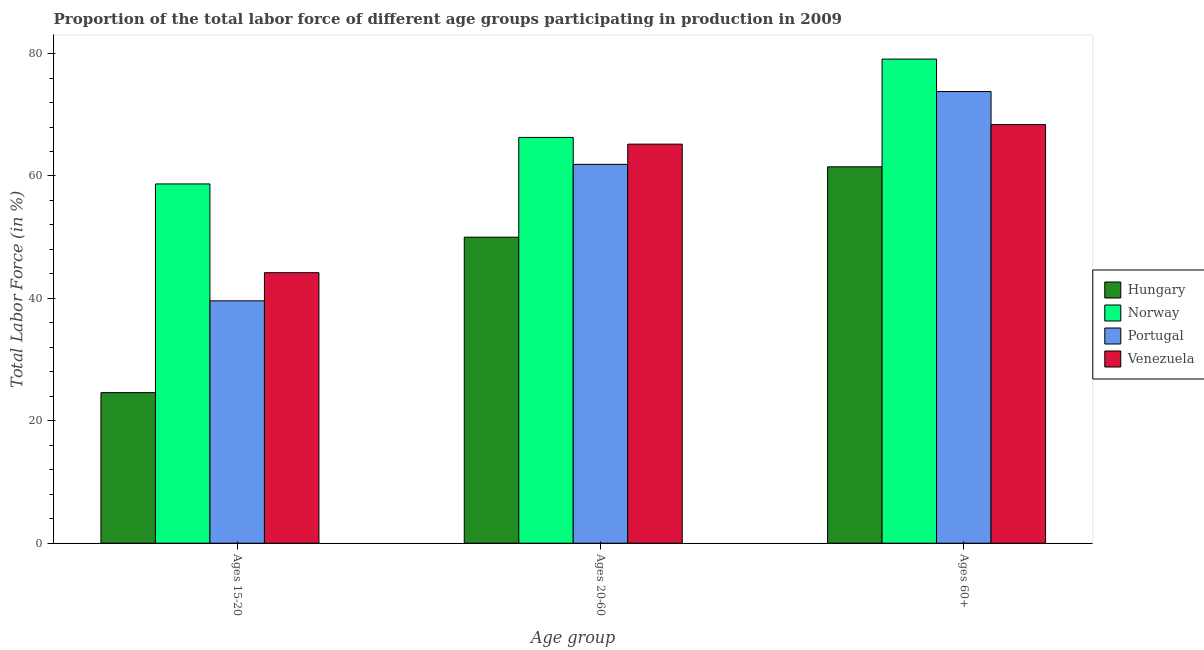How many groups of bars are there?
Your answer should be very brief. 3. Are the number of bars per tick equal to the number of legend labels?
Give a very brief answer. Yes. Are the number of bars on each tick of the X-axis equal?
Offer a very short reply. Yes. How many bars are there on the 3rd tick from the left?
Ensure brevity in your answer.  4. How many bars are there on the 3rd tick from the right?
Your answer should be compact. 4. What is the label of the 3rd group of bars from the left?
Provide a succinct answer. Ages 60+. What is the percentage of labor force above age 60 in Venezuela?
Your response must be concise. 68.4. Across all countries, what is the maximum percentage of labor force within the age group 15-20?
Make the answer very short. 58.7. In which country was the percentage of labor force within the age group 20-60 minimum?
Your response must be concise. Hungary. What is the total percentage of labor force within the age group 15-20 in the graph?
Offer a very short reply. 167.1. What is the difference between the percentage of labor force within the age group 20-60 in Venezuela and that in Norway?
Make the answer very short. -1.1. What is the difference between the percentage of labor force above age 60 in Norway and the percentage of labor force within the age group 15-20 in Hungary?
Ensure brevity in your answer.  54.5. What is the average percentage of labor force above age 60 per country?
Offer a very short reply. 70.7. What is the difference between the percentage of labor force within the age group 15-20 and percentage of labor force above age 60 in Portugal?
Keep it short and to the point. -34.2. What is the ratio of the percentage of labor force within the age group 20-60 in Venezuela to that in Hungary?
Provide a succinct answer. 1.3. Is the percentage of labor force above age 60 in Norway less than that in Hungary?
Offer a very short reply. No. Is the difference between the percentage of labor force above age 60 in Norway and Venezuela greater than the difference between the percentage of labor force within the age group 15-20 in Norway and Venezuela?
Your answer should be very brief. No. What is the difference between the highest and the second highest percentage of labor force within the age group 20-60?
Your response must be concise. 1.1. What is the difference between the highest and the lowest percentage of labor force above age 60?
Keep it short and to the point. 17.6. In how many countries, is the percentage of labor force above age 60 greater than the average percentage of labor force above age 60 taken over all countries?
Offer a terse response. 2. Is the sum of the percentage of labor force within the age group 20-60 in Hungary and Norway greater than the maximum percentage of labor force above age 60 across all countries?
Ensure brevity in your answer.  Yes. What does the 2nd bar from the left in Ages 15-20 represents?
Make the answer very short. Norway. What does the 1st bar from the right in Ages 20-60 represents?
Ensure brevity in your answer.  Venezuela. Is it the case that in every country, the sum of the percentage of labor force within the age group 15-20 and percentage of labor force within the age group 20-60 is greater than the percentage of labor force above age 60?
Keep it short and to the point. Yes. Are all the bars in the graph horizontal?
Your answer should be compact. No. How many legend labels are there?
Offer a very short reply. 4. How are the legend labels stacked?
Your answer should be compact. Vertical. What is the title of the graph?
Give a very brief answer. Proportion of the total labor force of different age groups participating in production in 2009. Does "Guam" appear as one of the legend labels in the graph?
Ensure brevity in your answer.  No. What is the label or title of the X-axis?
Your answer should be compact. Age group. What is the Total Labor Force (in %) of Hungary in Ages 15-20?
Give a very brief answer. 24.6. What is the Total Labor Force (in %) in Norway in Ages 15-20?
Ensure brevity in your answer.  58.7. What is the Total Labor Force (in %) in Portugal in Ages 15-20?
Make the answer very short. 39.6. What is the Total Labor Force (in %) in Venezuela in Ages 15-20?
Offer a terse response. 44.2. What is the Total Labor Force (in %) of Norway in Ages 20-60?
Make the answer very short. 66.3. What is the Total Labor Force (in %) of Portugal in Ages 20-60?
Provide a succinct answer. 61.9. What is the Total Labor Force (in %) in Venezuela in Ages 20-60?
Your answer should be very brief. 65.2. What is the Total Labor Force (in %) in Hungary in Ages 60+?
Provide a short and direct response. 61.5. What is the Total Labor Force (in %) of Norway in Ages 60+?
Keep it short and to the point. 79.1. What is the Total Labor Force (in %) of Portugal in Ages 60+?
Provide a short and direct response. 73.8. What is the Total Labor Force (in %) of Venezuela in Ages 60+?
Provide a succinct answer. 68.4. Across all Age group, what is the maximum Total Labor Force (in %) of Hungary?
Keep it short and to the point. 61.5. Across all Age group, what is the maximum Total Labor Force (in %) of Norway?
Your response must be concise. 79.1. Across all Age group, what is the maximum Total Labor Force (in %) of Portugal?
Offer a very short reply. 73.8. Across all Age group, what is the maximum Total Labor Force (in %) in Venezuela?
Ensure brevity in your answer.  68.4. Across all Age group, what is the minimum Total Labor Force (in %) of Hungary?
Your answer should be very brief. 24.6. Across all Age group, what is the minimum Total Labor Force (in %) of Norway?
Ensure brevity in your answer.  58.7. Across all Age group, what is the minimum Total Labor Force (in %) of Portugal?
Offer a very short reply. 39.6. Across all Age group, what is the minimum Total Labor Force (in %) of Venezuela?
Your response must be concise. 44.2. What is the total Total Labor Force (in %) in Hungary in the graph?
Your answer should be very brief. 136.1. What is the total Total Labor Force (in %) in Norway in the graph?
Offer a terse response. 204.1. What is the total Total Labor Force (in %) of Portugal in the graph?
Ensure brevity in your answer.  175.3. What is the total Total Labor Force (in %) in Venezuela in the graph?
Your answer should be very brief. 177.8. What is the difference between the Total Labor Force (in %) in Hungary in Ages 15-20 and that in Ages 20-60?
Your answer should be very brief. -25.4. What is the difference between the Total Labor Force (in %) in Norway in Ages 15-20 and that in Ages 20-60?
Your answer should be very brief. -7.6. What is the difference between the Total Labor Force (in %) in Portugal in Ages 15-20 and that in Ages 20-60?
Offer a very short reply. -22.3. What is the difference between the Total Labor Force (in %) in Hungary in Ages 15-20 and that in Ages 60+?
Give a very brief answer. -36.9. What is the difference between the Total Labor Force (in %) of Norway in Ages 15-20 and that in Ages 60+?
Offer a very short reply. -20.4. What is the difference between the Total Labor Force (in %) in Portugal in Ages 15-20 and that in Ages 60+?
Ensure brevity in your answer.  -34.2. What is the difference between the Total Labor Force (in %) in Venezuela in Ages 15-20 and that in Ages 60+?
Provide a short and direct response. -24.2. What is the difference between the Total Labor Force (in %) in Hungary in Ages 20-60 and that in Ages 60+?
Provide a succinct answer. -11.5. What is the difference between the Total Labor Force (in %) of Norway in Ages 20-60 and that in Ages 60+?
Make the answer very short. -12.8. What is the difference between the Total Labor Force (in %) of Hungary in Ages 15-20 and the Total Labor Force (in %) of Norway in Ages 20-60?
Make the answer very short. -41.7. What is the difference between the Total Labor Force (in %) in Hungary in Ages 15-20 and the Total Labor Force (in %) in Portugal in Ages 20-60?
Ensure brevity in your answer.  -37.3. What is the difference between the Total Labor Force (in %) of Hungary in Ages 15-20 and the Total Labor Force (in %) of Venezuela in Ages 20-60?
Keep it short and to the point. -40.6. What is the difference between the Total Labor Force (in %) of Norway in Ages 15-20 and the Total Labor Force (in %) of Venezuela in Ages 20-60?
Keep it short and to the point. -6.5. What is the difference between the Total Labor Force (in %) in Portugal in Ages 15-20 and the Total Labor Force (in %) in Venezuela in Ages 20-60?
Give a very brief answer. -25.6. What is the difference between the Total Labor Force (in %) in Hungary in Ages 15-20 and the Total Labor Force (in %) in Norway in Ages 60+?
Your answer should be very brief. -54.5. What is the difference between the Total Labor Force (in %) in Hungary in Ages 15-20 and the Total Labor Force (in %) in Portugal in Ages 60+?
Ensure brevity in your answer.  -49.2. What is the difference between the Total Labor Force (in %) of Hungary in Ages 15-20 and the Total Labor Force (in %) of Venezuela in Ages 60+?
Keep it short and to the point. -43.8. What is the difference between the Total Labor Force (in %) of Norway in Ages 15-20 and the Total Labor Force (in %) of Portugal in Ages 60+?
Your answer should be very brief. -15.1. What is the difference between the Total Labor Force (in %) of Norway in Ages 15-20 and the Total Labor Force (in %) of Venezuela in Ages 60+?
Your answer should be compact. -9.7. What is the difference between the Total Labor Force (in %) of Portugal in Ages 15-20 and the Total Labor Force (in %) of Venezuela in Ages 60+?
Keep it short and to the point. -28.8. What is the difference between the Total Labor Force (in %) of Hungary in Ages 20-60 and the Total Labor Force (in %) of Norway in Ages 60+?
Keep it short and to the point. -29.1. What is the difference between the Total Labor Force (in %) in Hungary in Ages 20-60 and the Total Labor Force (in %) in Portugal in Ages 60+?
Your response must be concise. -23.8. What is the difference between the Total Labor Force (in %) in Hungary in Ages 20-60 and the Total Labor Force (in %) in Venezuela in Ages 60+?
Your response must be concise. -18.4. What is the difference between the Total Labor Force (in %) in Norway in Ages 20-60 and the Total Labor Force (in %) in Portugal in Ages 60+?
Keep it short and to the point. -7.5. What is the difference between the Total Labor Force (in %) in Portugal in Ages 20-60 and the Total Labor Force (in %) in Venezuela in Ages 60+?
Your answer should be very brief. -6.5. What is the average Total Labor Force (in %) in Hungary per Age group?
Give a very brief answer. 45.37. What is the average Total Labor Force (in %) of Norway per Age group?
Offer a very short reply. 68.03. What is the average Total Labor Force (in %) in Portugal per Age group?
Keep it short and to the point. 58.43. What is the average Total Labor Force (in %) in Venezuela per Age group?
Keep it short and to the point. 59.27. What is the difference between the Total Labor Force (in %) of Hungary and Total Labor Force (in %) of Norway in Ages 15-20?
Provide a short and direct response. -34.1. What is the difference between the Total Labor Force (in %) in Hungary and Total Labor Force (in %) in Portugal in Ages 15-20?
Your answer should be very brief. -15. What is the difference between the Total Labor Force (in %) of Hungary and Total Labor Force (in %) of Venezuela in Ages 15-20?
Offer a very short reply. -19.6. What is the difference between the Total Labor Force (in %) of Norway and Total Labor Force (in %) of Venezuela in Ages 15-20?
Your answer should be very brief. 14.5. What is the difference between the Total Labor Force (in %) in Portugal and Total Labor Force (in %) in Venezuela in Ages 15-20?
Offer a very short reply. -4.6. What is the difference between the Total Labor Force (in %) in Hungary and Total Labor Force (in %) in Norway in Ages 20-60?
Provide a succinct answer. -16.3. What is the difference between the Total Labor Force (in %) of Hungary and Total Labor Force (in %) of Portugal in Ages 20-60?
Offer a very short reply. -11.9. What is the difference between the Total Labor Force (in %) of Hungary and Total Labor Force (in %) of Venezuela in Ages 20-60?
Your answer should be very brief. -15.2. What is the difference between the Total Labor Force (in %) in Norway and Total Labor Force (in %) in Portugal in Ages 20-60?
Your response must be concise. 4.4. What is the difference between the Total Labor Force (in %) of Portugal and Total Labor Force (in %) of Venezuela in Ages 20-60?
Make the answer very short. -3.3. What is the difference between the Total Labor Force (in %) in Hungary and Total Labor Force (in %) in Norway in Ages 60+?
Keep it short and to the point. -17.6. What is the difference between the Total Labor Force (in %) of Hungary and Total Labor Force (in %) of Venezuela in Ages 60+?
Make the answer very short. -6.9. What is the difference between the Total Labor Force (in %) of Norway and Total Labor Force (in %) of Venezuela in Ages 60+?
Give a very brief answer. 10.7. What is the difference between the Total Labor Force (in %) in Portugal and Total Labor Force (in %) in Venezuela in Ages 60+?
Make the answer very short. 5.4. What is the ratio of the Total Labor Force (in %) in Hungary in Ages 15-20 to that in Ages 20-60?
Your response must be concise. 0.49. What is the ratio of the Total Labor Force (in %) in Norway in Ages 15-20 to that in Ages 20-60?
Provide a short and direct response. 0.89. What is the ratio of the Total Labor Force (in %) in Portugal in Ages 15-20 to that in Ages 20-60?
Ensure brevity in your answer.  0.64. What is the ratio of the Total Labor Force (in %) of Venezuela in Ages 15-20 to that in Ages 20-60?
Provide a succinct answer. 0.68. What is the ratio of the Total Labor Force (in %) of Hungary in Ages 15-20 to that in Ages 60+?
Keep it short and to the point. 0.4. What is the ratio of the Total Labor Force (in %) of Norway in Ages 15-20 to that in Ages 60+?
Keep it short and to the point. 0.74. What is the ratio of the Total Labor Force (in %) in Portugal in Ages 15-20 to that in Ages 60+?
Your response must be concise. 0.54. What is the ratio of the Total Labor Force (in %) of Venezuela in Ages 15-20 to that in Ages 60+?
Your answer should be very brief. 0.65. What is the ratio of the Total Labor Force (in %) of Hungary in Ages 20-60 to that in Ages 60+?
Keep it short and to the point. 0.81. What is the ratio of the Total Labor Force (in %) in Norway in Ages 20-60 to that in Ages 60+?
Make the answer very short. 0.84. What is the ratio of the Total Labor Force (in %) of Portugal in Ages 20-60 to that in Ages 60+?
Give a very brief answer. 0.84. What is the ratio of the Total Labor Force (in %) in Venezuela in Ages 20-60 to that in Ages 60+?
Your response must be concise. 0.95. What is the difference between the highest and the second highest Total Labor Force (in %) of Hungary?
Give a very brief answer. 11.5. What is the difference between the highest and the second highest Total Labor Force (in %) in Norway?
Offer a very short reply. 12.8. What is the difference between the highest and the lowest Total Labor Force (in %) of Hungary?
Make the answer very short. 36.9. What is the difference between the highest and the lowest Total Labor Force (in %) of Norway?
Make the answer very short. 20.4. What is the difference between the highest and the lowest Total Labor Force (in %) of Portugal?
Your answer should be very brief. 34.2. What is the difference between the highest and the lowest Total Labor Force (in %) of Venezuela?
Offer a very short reply. 24.2. 